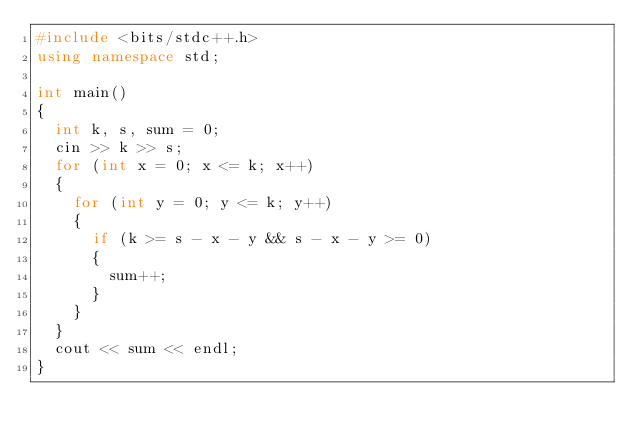Convert code to text. <code><loc_0><loc_0><loc_500><loc_500><_C++_>#include <bits/stdc++.h>
using namespace std;

int main()
{
  int k, s, sum = 0;
  cin >> k >> s;
  for (int x = 0; x <= k; x++)
  {
    for (int y = 0; y <= k; y++)
    {
      if (k >= s - x - y && s - x - y >= 0)
      {
        sum++;
      }
    }
  }
  cout << sum << endl;
}
</code> 